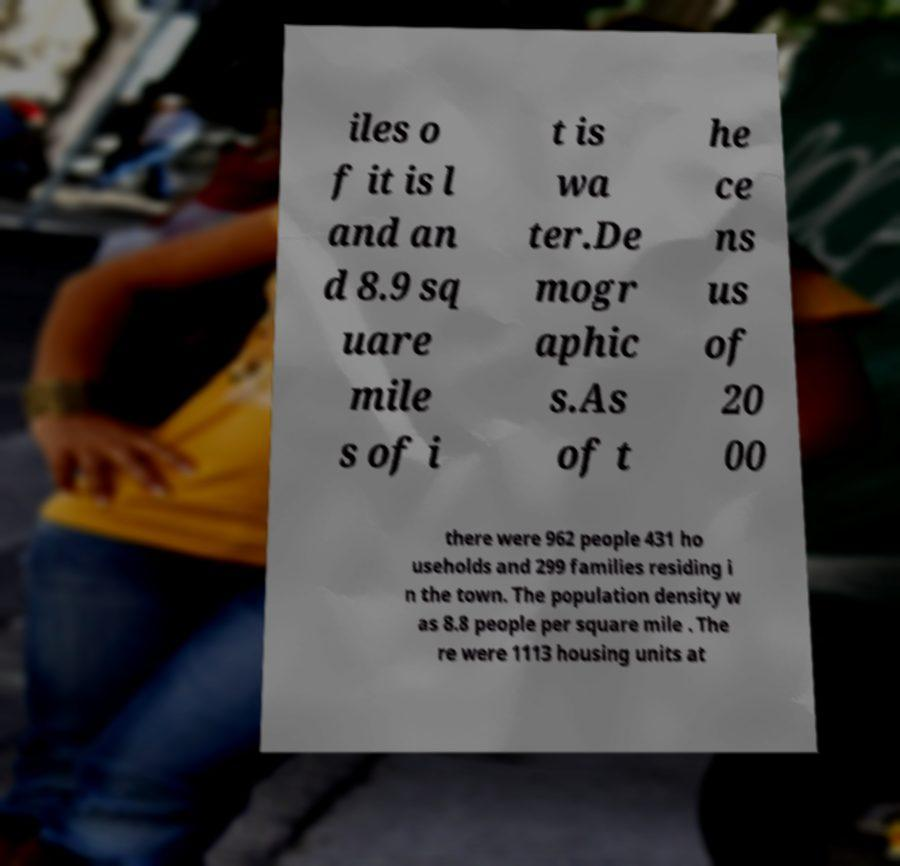Could you assist in decoding the text presented in this image and type it out clearly? iles o f it is l and an d 8.9 sq uare mile s of i t is wa ter.De mogr aphic s.As of t he ce ns us of 20 00 there were 962 people 431 ho useholds and 299 families residing i n the town. The population density w as 8.8 people per square mile . The re were 1113 housing units at 